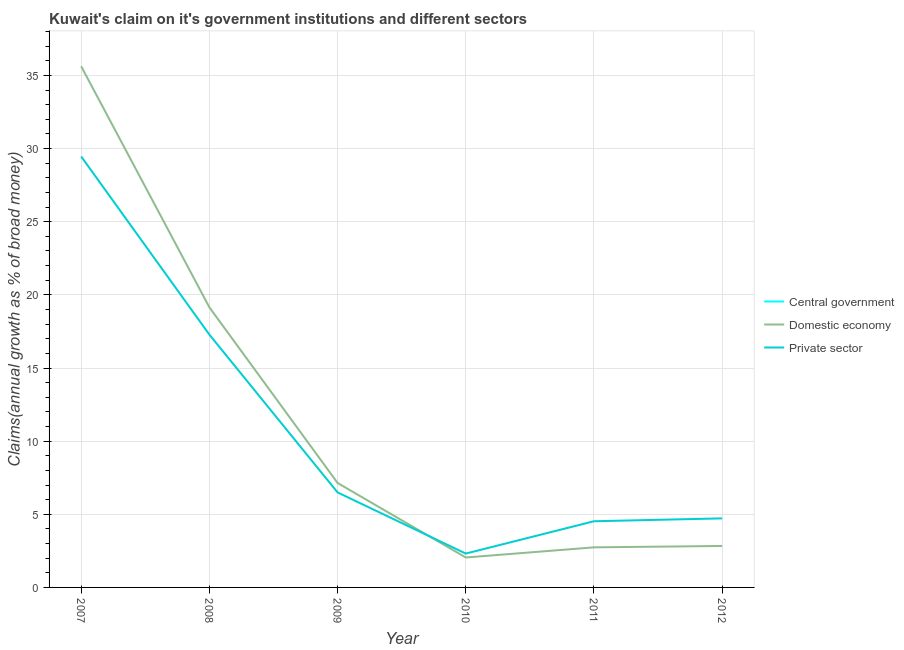Does the line corresponding to percentage of claim on the domestic economy intersect with the line corresponding to percentage of claim on the central government?
Keep it short and to the point. No. Is the number of lines equal to the number of legend labels?
Provide a short and direct response. No. What is the percentage of claim on the private sector in 2009?
Provide a short and direct response. 6.5. Across all years, what is the maximum percentage of claim on the private sector?
Keep it short and to the point. 29.46. Across all years, what is the minimum percentage of claim on the domestic economy?
Ensure brevity in your answer.  2.05. What is the total percentage of claim on the domestic economy in the graph?
Keep it short and to the point. 69.53. What is the difference between the percentage of claim on the private sector in 2008 and that in 2009?
Provide a short and direct response. 10.79. What is the difference between the percentage of claim on the domestic economy in 2010 and the percentage of claim on the private sector in 2007?
Offer a very short reply. -27.41. What is the average percentage of claim on the domestic economy per year?
Your answer should be compact. 11.59. In the year 2011, what is the difference between the percentage of claim on the private sector and percentage of claim on the domestic economy?
Provide a succinct answer. 1.78. In how many years, is the percentage of claim on the central government greater than 16 %?
Your answer should be very brief. 0. What is the ratio of the percentage of claim on the domestic economy in 2007 to that in 2008?
Your answer should be compact. 1.86. What is the difference between the highest and the second highest percentage of claim on the domestic economy?
Provide a short and direct response. 16.48. What is the difference between the highest and the lowest percentage of claim on the private sector?
Offer a terse response. 27.15. In how many years, is the percentage of claim on the private sector greater than the average percentage of claim on the private sector taken over all years?
Ensure brevity in your answer.  2. Is it the case that in every year, the sum of the percentage of claim on the central government and percentage of claim on the domestic economy is greater than the percentage of claim on the private sector?
Offer a terse response. No. Is the percentage of claim on the domestic economy strictly less than the percentage of claim on the central government over the years?
Provide a short and direct response. No. How many lines are there?
Offer a terse response. 2. How many years are there in the graph?
Offer a terse response. 6. Does the graph contain any zero values?
Make the answer very short. Yes. Where does the legend appear in the graph?
Ensure brevity in your answer.  Center right. What is the title of the graph?
Your answer should be compact. Kuwait's claim on it's government institutions and different sectors. What is the label or title of the X-axis?
Provide a succinct answer. Year. What is the label or title of the Y-axis?
Your answer should be very brief. Claims(annual growth as % of broad money). What is the Claims(annual growth as % of broad money) in Domestic economy in 2007?
Your answer should be compact. 35.63. What is the Claims(annual growth as % of broad money) of Private sector in 2007?
Keep it short and to the point. 29.46. What is the Claims(annual growth as % of broad money) of Central government in 2008?
Ensure brevity in your answer.  0. What is the Claims(annual growth as % of broad money) in Domestic economy in 2008?
Provide a succinct answer. 19.15. What is the Claims(annual growth as % of broad money) of Private sector in 2008?
Your answer should be very brief. 17.28. What is the Claims(annual growth as % of broad money) in Central government in 2009?
Ensure brevity in your answer.  0. What is the Claims(annual growth as % of broad money) in Domestic economy in 2009?
Provide a short and direct response. 7.14. What is the Claims(annual growth as % of broad money) of Private sector in 2009?
Offer a very short reply. 6.5. What is the Claims(annual growth as % of broad money) in Central government in 2010?
Provide a short and direct response. 0. What is the Claims(annual growth as % of broad money) of Domestic economy in 2010?
Provide a short and direct response. 2.05. What is the Claims(annual growth as % of broad money) in Private sector in 2010?
Provide a succinct answer. 2.31. What is the Claims(annual growth as % of broad money) in Central government in 2011?
Your response must be concise. 0. What is the Claims(annual growth as % of broad money) in Domestic economy in 2011?
Offer a very short reply. 2.74. What is the Claims(annual growth as % of broad money) in Private sector in 2011?
Your response must be concise. 4.52. What is the Claims(annual growth as % of broad money) in Central government in 2012?
Provide a short and direct response. 0. What is the Claims(annual growth as % of broad money) of Domestic economy in 2012?
Offer a terse response. 2.83. What is the Claims(annual growth as % of broad money) in Private sector in 2012?
Provide a succinct answer. 4.72. Across all years, what is the maximum Claims(annual growth as % of broad money) in Domestic economy?
Offer a very short reply. 35.63. Across all years, what is the maximum Claims(annual growth as % of broad money) in Private sector?
Provide a short and direct response. 29.46. Across all years, what is the minimum Claims(annual growth as % of broad money) of Domestic economy?
Ensure brevity in your answer.  2.05. Across all years, what is the minimum Claims(annual growth as % of broad money) of Private sector?
Your response must be concise. 2.31. What is the total Claims(annual growth as % of broad money) of Central government in the graph?
Offer a very short reply. 0. What is the total Claims(annual growth as % of broad money) in Domestic economy in the graph?
Keep it short and to the point. 69.53. What is the total Claims(annual growth as % of broad money) in Private sector in the graph?
Your answer should be very brief. 64.8. What is the difference between the Claims(annual growth as % of broad money) of Domestic economy in 2007 and that in 2008?
Keep it short and to the point. 16.48. What is the difference between the Claims(annual growth as % of broad money) in Private sector in 2007 and that in 2008?
Make the answer very short. 12.18. What is the difference between the Claims(annual growth as % of broad money) of Domestic economy in 2007 and that in 2009?
Keep it short and to the point. 28.49. What is the difference between the Claims(annual growth as % of broad money) in Private sector in 2007 and that in 2009?
Keep it short and to the point. 22.96. What is the difference between the Claims(annual growth as % of broad money) in Domestic economy in 2007 and that in 2010?
Offer a terse response. 33.58. What is the difference between the Claims(annual growth as % of broad money) in Private sector in 2007 and that in 2010?
Give a very brief answer. 27.15. What is the difference between the Claims(annual growth as % of broad money) in Domestic economy in 2007 and that in 2011?
Give a very brief answer. 32.89. What is the difference between the Claims(annual growth as % of broad money) in Private sector in 2007 and that in 2011?
Your answer should be very brief. 24.94. What is the difference between the Claims(annual growth as % of broad money) in Domestic economy in 2007 and that in 2012?
Give a very brief answer. 32.79. What is the difference between the Claims(annual growth as % of broad money) in Private sector in 2007 and that in 2012?
Offer a terse response. 24.74. What is the difference between the Claims(annual growth as % of broad money) in Domestic economy in 2008 and that in 2009?
Provide a short and direct response. 12.01. What is the difference between the Claims(annual growth as % of broad money) of Private sector in 2008 and that in 2009?
Your answer should be very brief. 10.79. What is the difference between the Claims(annual growth as % of broad money) in Domestic economy in 2008 and that in 2010?
Your response must be concise. 17.1. What is the difference between the Claims(annual growth as % of broad money) in Private sector in 2008 and that in 2010?
Provide a succinct answer. 14.97. What is the difference between the Claims(annual growth as % of broad money) in Domestic economy in 2008 and that in 2011?
Keep it short and to the point. 16.41. What is the difference between the Claims(annual growth as % of broad money) of Private sector in 2008 and that in 2011?
Offer a very short reply. 12.76. What is the difference between the Claims(annual growth as % of broad money) of Domestic economy in 2008 and that in 2012?
Ensure brevity in your answer.  16.31. What is the difference between the Claims(annual growth as % of broad money) in Private sector in 2008 and that in 2012?
Your response must be concise. 12.56. What is the difference between the Claims(annual growth as % of broad money) of Domestic economy in 2009 and that in 2010?
Give a very brief answer. 5.09. What is the difference between the Claims(annual growth as % of broad money) of Private sector in 2009 and that in 2010?
Provide a short and direct response. 4.18. What is the difference between the Claims(annual growth as % of broad money) in Domestic economy in 2009 and that in 2011?
Offer a very short reply. 4.4. What is the difference between the Claims(annual growth as % of broad money) in Private sector in 2009 and that in 2011?
Keep it short and to the point. 1.97. What is the difference between the Claims(annual growth as % of broad money) of Domestic economy in 2009 and that in 2012?
Your response must be concise. 4.31. What is the difference between the Claims(annual growth as % of broad money) of Private sector in 2009 and that in 2012?
Your answer should be compact. 1.77. What is the difference between the Claims(annual growth as % of broad money) of Domestic economy in 2010 and that in 2011?
Your answer should be very brief. -0.69. What is the difference between the Claims(annual growth as % of broad money) of Private sector in 2010 and that in 2011?
Your answer should be compact. -2.21. What is the difference between the Claims(annual growth as % of broad money) in Domestic economy in 2010 and that in 2012?
Ensure brevity in your answer.  -0.79. What is the difference between the Claims(annual growth as % of broad money) of Private sector in 2010 and that in 2012?
Your response must be concise. -2.41. What is the difference between the Claims(annual growth as % of broad money) of Domestic economy in 2011 and that in 2012?
Offer a very short reply. -0.09. What is the difference between the Claims(annual growth as % of broad money) of Private sector in 2011 and that in 2012?
Make the answer very short. -0.2. What is the difference between the Claims(annual growth as % of broad money) of Domestic economy in 2007 and the Claims(annual growth as % of broad money) of Private sector in 2008?
Your response must be concise. 18.34. What is the difference between the Claims(annual growth as % of broad money) of Domestic economy in 2007 and the Claims(annual growth as % of broad money) of Private sector in 2009?
Ensure brevity in your answer.  29.13. What is the difference between the Claims(annual growth as % of broad money) in Domestic economy in 2007 and the Claims(annual growth as % of broad money) in Private sector in 2010?
Offer a very short reply. 33.31. What is the difference between the Claims(annual growth as % of broad money) of Domestic economy in 2007 and the Claims(annual growth as % of broad money) of Private sector in 2011?
Your response must be concise. 31.1. What is the difference between the Claims(annual growth as % of broad money) of Domestic economy in 2007 and the Claims(annual growth as % of broad money) of Private sector in 2012?
Keep it short and to the point. 30.91. What is the difference between the Claims(annual growth as % of broad money) of Domestic economy in 2008 and the Claims(annual growth as % of broad money) of Private sector in 2009?
Provide a short and direct response. 12.65. What is the difference between the Claims(annual growth as % of broad money) in Domestic economy in 2008 and the Claims(annual growth as % of broad money) in Private sector in 2010?
Your response must be concise. 16.83. What is the difference between the Claims(annual growth as % of broad money) of Domestic economy in 2008 and the Claims(annual growth as % of broad money) of Private sector in 2011?
Keep it short and to the point. 14.62. What is the difference between the Claims(annual growth as % of broad money) in Domestic economy in 2008 and the Claims(annual growth as % of broad money) in Private sector in 2012?
Offer a very short reply. 14.43. What is the difference between the Claims(annual growth as % of broad money) of Domestic economy in 2009 and the Claims(annual growth as % of broad money) of Private sector in 2010?
Provide a succinct answer. 4.83. What is the difference between the Claims(annual growth as % of broad money) in Domestic economy in 2009 and the Claims(annual growth as % of broad money) in Private sector in 2011?
Provide a succinct answer. 2.62. What is the difference between the Claims(annual growth as % of broad money) of Domestic economy in 2009 and the Claims(annual growth as % of broad money) of Private sector in 2012?
Provide a short and direct response. 2.42. What is the difference between the Claims(annual growth as % of broad money) of Domestic economy in 2010 and the Claims(annual growth as % of broad money) of Private sector in 2011?
Offer a terse response. -2.48. What is the difference between the Claims(annual growth as % of broad money) of Domestic economy in 2010 and the Claims(annual growth as % of broad money) of Private sector in 2012?
Provide a succinct answer. -2.67. What is the difference between the Claims(annual growth as % of broad money) of Domestic economy in 2011 and the Claims(annual growth as % of broad money) of Private sector in 2012?
Your answer should be very brief. -1.98. What is the average Claims(annual growth as % of broad money) of Central government per year?
Your answer should be compact. 0. What is the average Claims(annual growth as % of broad money) in Domestic economy per year?
Your response must be concise. 11.59. What is the average Claims(annual growth as % of broad money) in Private sector per year?
Your answer should be compact. 10.8. In the year 2007, what is the difference between the Claims(annual growth as % of broad money) in Domestic economy and Claims(annual growth as % of broad money) in Private sector?
Your answer should be very brief. 6.17. In the year 2008, what is the difference between the Claims(annual growth as % of broad money) in Domestic economy and Claims(annual growth as % of broad money) in Private sector?
Give a very brief answer. 1.86. In the year 2009, what is the difference between the Claims(annual growth as % of broad money) of Domestic economy and Claims(annual growth as % of broad money) of Private sector?
Ensure brevity in your answer.  0.65. In the year 2010, what is the difference between the Claims(annual growth as % of broad money) in Domestic economy and Claims(annual growth as % of broad money) in Private sector?
Give a very brief answer. -0.27. In the year 2011, what is the difference between the Claims(annual growth as % of broad money) of Domestic economy and Claims(annual growth as % of broad money) of Private sector?
Give a very brief answer. -1.78. In the year 2012, what is the difference between the Claims(annual growth as % of broad money) of Domestic economy and Claims(annual growth as % of broad money) of Private sector?
Make the answer very short. -1.89. What is the ratio of the Claims(annual growth as % of broad money) in Domestic economy in 2007 to that in 2008?
Provide a succinct answer. 1.86. What is the ratio of the Claims(annual growth as % of broad money) of Private sector in 2007 to that in 2008?
Give a very brief answer. 1.7. What is the ratio of the Claims(annual growth as % of broad money) in Domestic economy in 2007 to that in 2009?
Provide a short and direct response. 4.99. What is the ratio of the Claims(annual growth as % of broad money) in Private sector in 2007 to that in 2009?
Your answer should be compact. 4.54. What is the ratio of the Claims(annual growth as % of broad money) in Domestic economy in 2007 to that in 2010?
Provide a short and direct response. 17.4. What is the ratio of the Claims(annual growth as % of broad money) in Private sector in 2007 to that in 2010?
Keep it short and to the point. 12.73. What is the ratio of the Claims(annual growth as % of broad money) in Domestic economy in 2007 to that in 2011?
Offer a terse response. 13. What is the ratio of the Claims(annual growth as % of broad money) in Private sector in 2007 to that in 2011?
Offer a very short reply. 6.51. What is the ratio of the Claims(annual growth as % of broad money) in Domestic economy in 2007 to that in 2012?
Make the answer very short. 12.57. What is the ratio of the Claims(annual growth as % of broad money) in Private sector in 2007 to that in 2012?
Keep it short and to the point. 6.24. What is the ratio of the Claims(annual growth as % of broad money) in Domestic economy in 2008 to that in 2009?
Offer a very short reply. 2.68. What is the ratio of the Claims(annual growth as % of broad money) of Private sector in 2008 to that in 2009?
Your response must be concise. 2.66. What is the ratio of the Claims(annual growth as % of broad money) in Domestic economy in 2008 to that in 2010?
Ensure brevity in your answer.  9.35. What is the ratio of the Claims(annual growth as % of broad money) of Private sector in 2008 to that in 2010?
Ensure brevity in your answer.  7.47. What is the ratio of the Claims(annual growth as % of broad money) in Domestic economy in 2008 to that in 2011?
Offer a terse response. 6.99. What is the ratio of the Claims(annual growth as % of broad money) in Private sector in 2008 to that in 2011?
Your response must be concise. 3.82. What is the ratio of the Claims(annual growth as % of broad money) of Domestic economy in 2008 to that in 2012?
Give a very brief answer. 6.76. What is the ratio of the Claims(annual growth as % of broad money) of Private sector in 2008 to that in 2012?
Your answer should be very brief. 3.66. What is the ratio of the Claims(annual growth as % of broad money) in Domestic economy in 2009 to that in 2010?
Offer a very short reply. 3.49. What is the ratio of the Claims(annual growth as % of broad money) of Private sector in 2009 to that in 2010?
Provide a short and direct response. 2.81. What is the ratio of the Claims(annual growth as % of broad money) in Domestic economy in 2009 to that in 2011?
Keep it short and to the point. 2.61. What is the ratio of the Claims(annual growth as % of broad money) of Private sector in 2009 to that in 2011?
Make the answer very short. 1.44. What is the ratio of the Claims(annual growth as % of broad money) of Domestic economy in 2009 to that in 2012?
Offer a terse response. 2.52. What is the ratio of the Claims(annual growth as % of broad money) in Private sector in 2009 to that in 2012?
Ensure brevity in your answer.  1.38. What is the ratio of the Claims(annual growth as % of broad money) in Domestic economy in 2010 to that in 2011?
Ensure brevity in your answer.  0.75. What is the ratio of the Claims(annual growth as % of broad money) in Private sector in 2010 to that in 2011?
Give a very brief answer. 0.51. What is the ratio of the Claims(annual growth as % of broad money) of Domestic economy in 2010 to that in 2012?
Your answer should be compact. 0.72. What is the ratio of the Claims(annual growth as % of broad money) of Private sector in 2010 to that in 2012?
Offer a very short reply. 0.49. What is the ratio of the Claims(annual growth as % of broad money) of Domestic economy in 2011 to that in 2012?
Your answer should be very brief. 0.97. What is the ratio of the Claims(annual growth as % of broad money) in Private sector in 2011 to that in 2012?
Make the answer very short. 0.96. What is the difference between the highest and the second highest Claims(annual growth as % of broad money) of Domestic economy?
Your answer should be compact. 16.48. What is the difference between the highest and the second highest Claims(annual growth as % of broad money) in Private sector?
Keep it short and to the point. 12.18. What is the difference between the highest and the lowest Claims(annual growth as % of broad money) of Domestic economy?
Keep it short and to the point. 33.58. What is the difference between the highest and the lowest Claims(annual growth as % of broad money) of Private sector?
Provide a succinct answer. 27.15. 